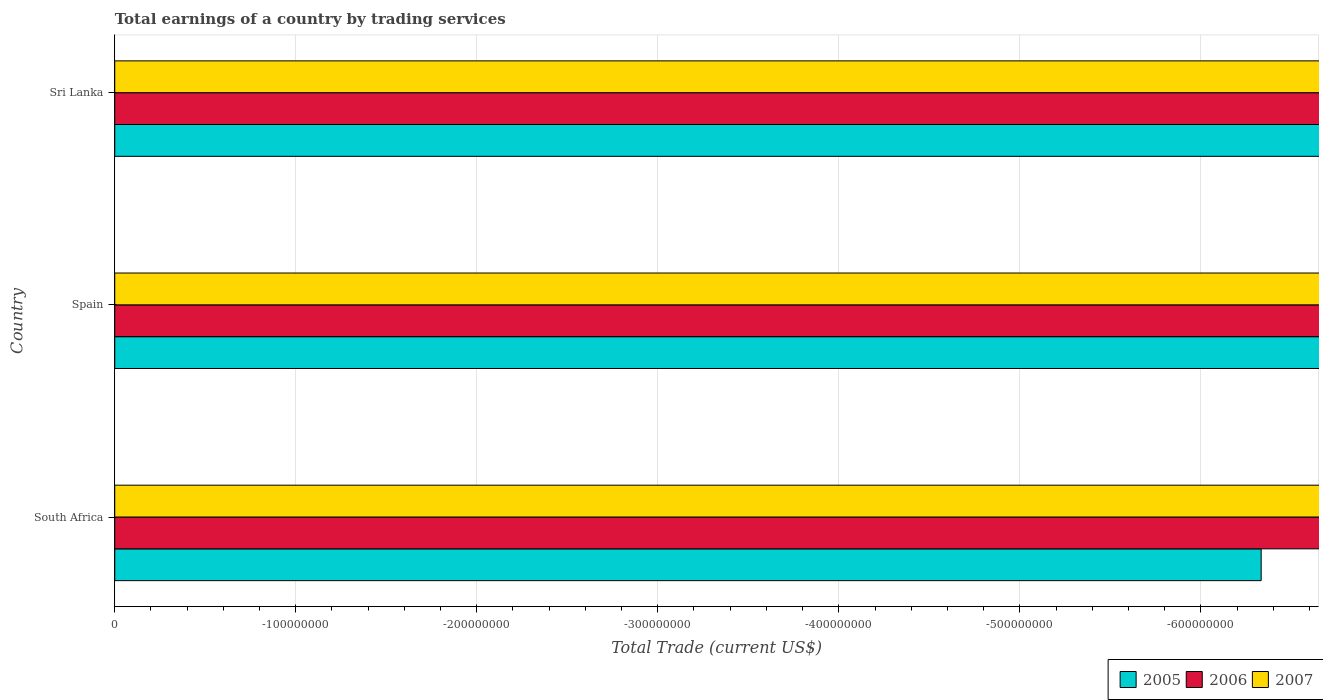Are the number of bars per tick equal to the number of legend labels?
Offer a very short reply. No. How many bars are there on the 3rd tick from the top?
Offer a very short reply. 0. What is the label of the 1st group of bars from the top?
Give a very brief answer. Sri Lanka. In how many cases, is the number of bars for a given country not equal to the number of legend labels?
Your response must be concise. 3. What is the total earnings in 2006 in Sri Lanka?
Offer a terse response. 0. Across all countries, what is the minimum total earnings in 2006?
Ensure brevity in your answer.  0. What is the total total earnings in 2005 in the graph?
Your answer should be very brief. 0. What is the average total earnings in 2007 per country?
Your answer should be compact. 0. In how many countries, is the total earnings in 2005 greater than -140000000 US$?
Provide a short and direct response. 0. Are all the bars in the graph horizontal?
Provide a succinct answer. Yes. Does the graph contain any zero values?
Ensure brevity in your answer.  Yes. Does the graph contain grids?
Your response must be concise. Yes. How many legend labels are there?
Provide a short and direct response. 3. How are the legend labels stacked?
Make the answer very short. Horizontal. What is the title of the graph?
Keep it short and to the point. Total earnings of a country by trading services. Does "1972" appear as one of the legend labels in the graph?
Provide a short and direct response. No. What is the label or title of the X-axis?
Keep it short and to the point. Total Trade (current US$). What is the label or title of the Y-axis?
Provide a succinct answer. Country. What is the Total Trade (current US$) of 2005 in South Africa?
Your response must be concise. 0. What is the Total Trade (current US$) in 2007 in Spain?
Keep it short and to the point. 0. What is the Total Trade (current US$) in 2005 in Sri Lanka?
Provide a short and direct response. 0. What is the Total Trade (current US$) of 2006 in Sri Lanka?
Your answer should be very brief. 0. What is the total Total Trade (current US$) of 2005 in the graph?
Make the answer very short. 0. What is the total Total Trade (current US$) of 2007 in the graph?
Your response must be concise. 0. 